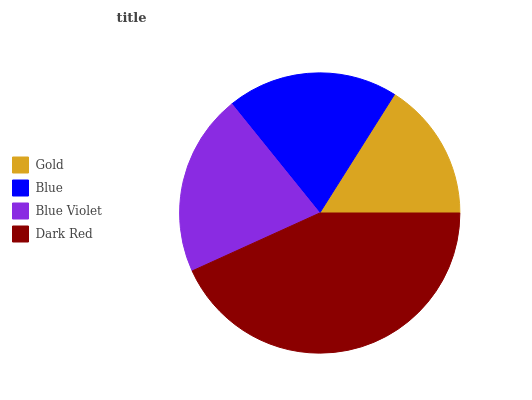Is Gold the minimum?
Answer yes or no. Yes. Is Dark Red the maximum?
Answer yes or no. Yes. Is Blue the minimum?
Answer yes or no. No. Is Blue the maximum?
Answer yes or no. No. Is Blue greater than Gold?
Answer yes or no. Yes. Is Gold less than Blue?
Answer yes or no. Yes. Is Gold greater than Blue?
Answer yes or no. No. Is Blue less than Gold?
Answer yes or no. No. Is Blue Violet the high median?
Answer yes or no. Yes. Is Blue the low median?
Answer yes or no. Yes. Is Blue the high median?
Answer yes or no. No. Is Dark Red the low median?
Answer yes or no. No. 